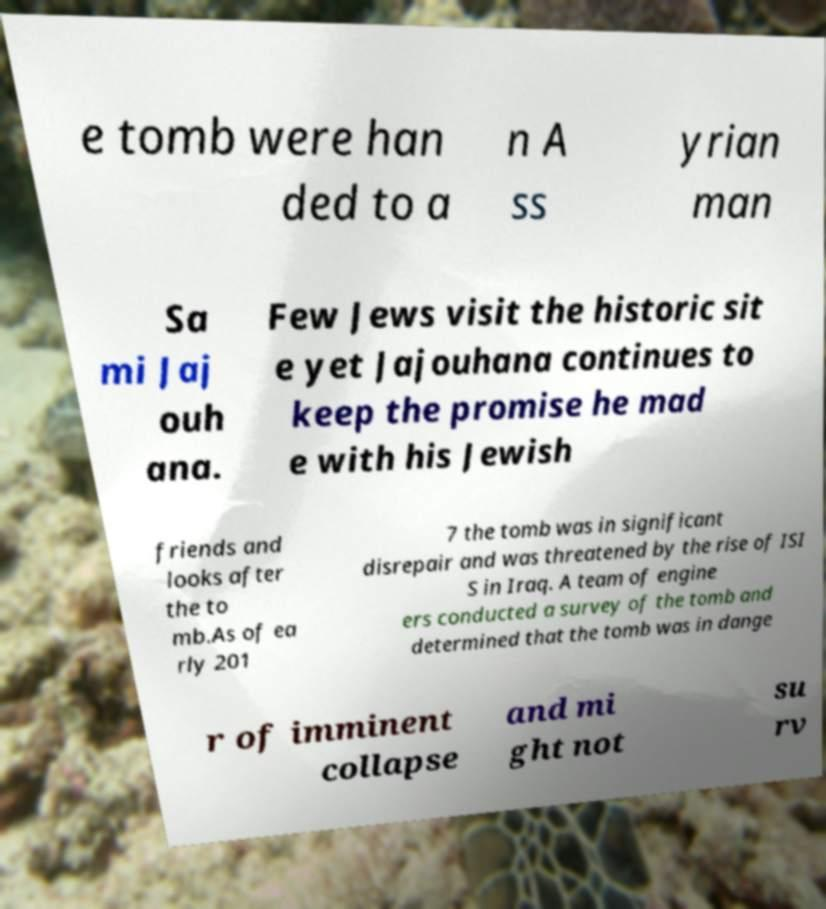Can you read and provide the text displayed in the image?This photo seems to have some interesting text. Can you extract and type it out for me? e tomb were han ded to a n A ss yrian man Sa mi Jaj ouh ana. Few Jews visit the historic sit e yet Jajouhana continues to keep the promise he mad e with his Jewish friends and looks after the to mb.As of ea rly 201 7 the tomb was in significant disrepair and was threatened by the rise of ISI S in Iraq. A team of engine ers conducted a survey of the tomb and determined that the tomb was in dange r of imminent collapse and mi ght not su rv 